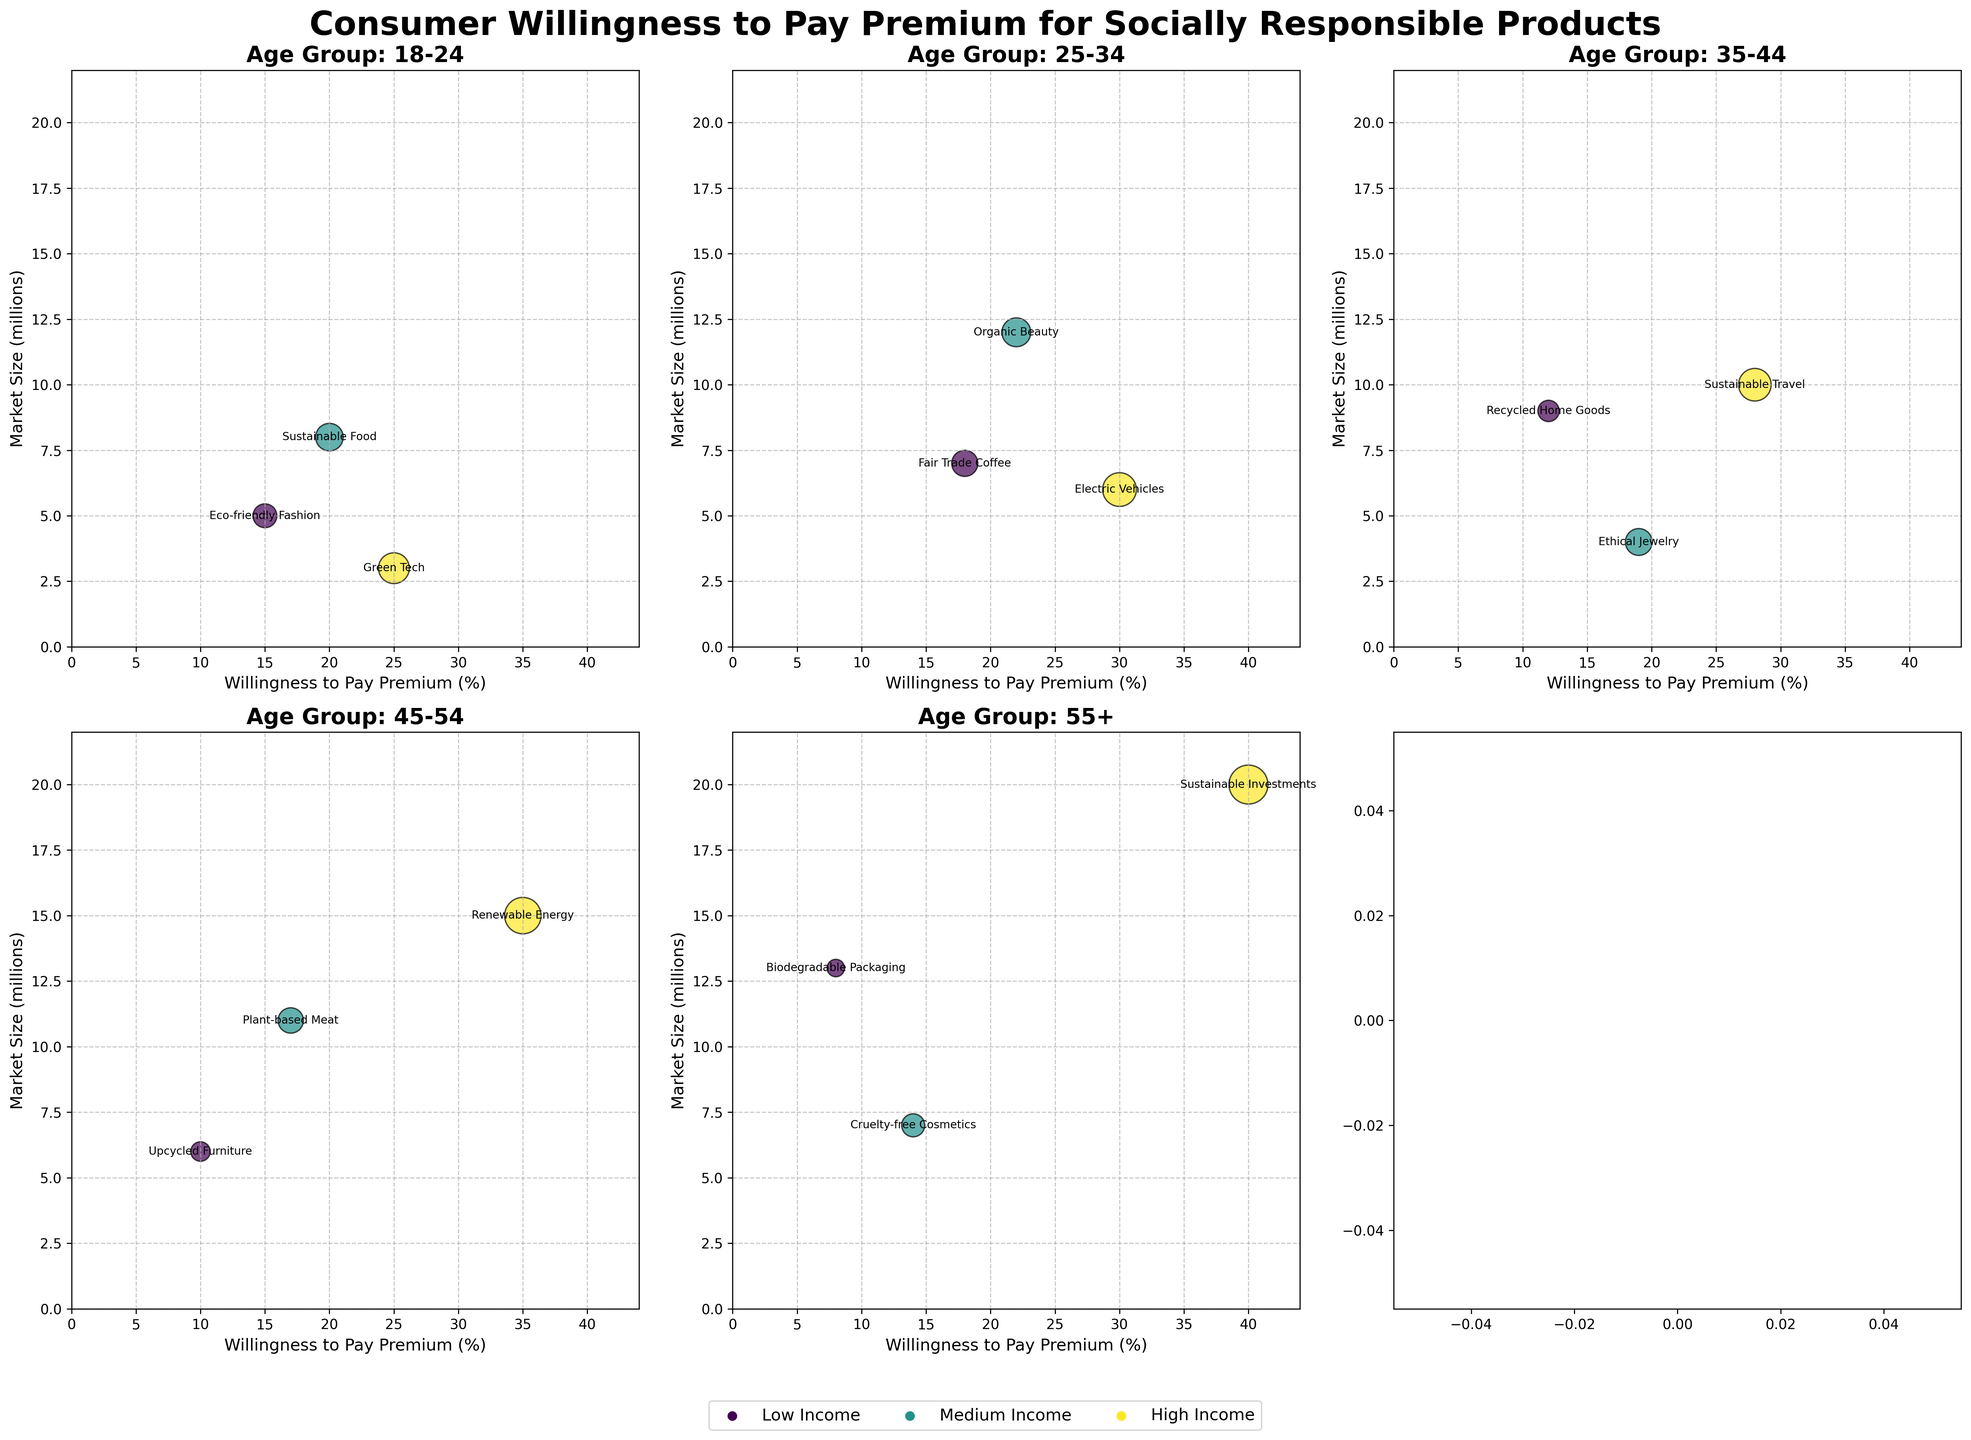What is the title of the figure? The title of the figure is displayed at the top of the plot area and usually provides an overview of what the entire figure is about.
Answer: Consumer Willingness to Pay Premium for Socially Responsible Products Which age group shows the highest willingness to pay a premium for any product? When looking at the subplots for different age groups, identify the maximum value on the x-axis labeled 'Willingness to Pay Premium (%)'.
Answer: 55+ (Sustainable Investments, 40%) What is the market size for Electric Vehicles for the age group 25-34? Find the subplot for the age group 25-34 and locate the bubble labeled 'Electric Vehicles'. The y-axis represents the market size.
Answer: 6 million How many products are represented in the age group 35-44? Count the number of bubbles in the subplot for the age group 35-44. Each bubble represents a different product.
Answer: 3 Compare the willingness to pay premiums between 18-24 and 45-54 age groups. Which age group shows more willingness to pay premiums for their products in general? Look at the x-axis ranges and individual bubble positions for the subplots of 18-24 and 45-54 age groups. Compare the positions on the x-axis for higher values.
Answer: 18-24 What is the product category for low-income individuals in the age group 45-54, and what is its willingness to pay premium percentage? Find the subplot for the age group 45-54, locate the specific bubble color corresponding to low-income levels and read its label and corresponding x-axis value.
Answer: Upcycled Furniture, 10% For the age group 25-34, what is the difference in willingness to pay premiums between Organic Beauty (Medium Income) and Fair Trade Coffee (Low Income)? Locate the bubbles for Organic Beauty and Fair Trade Coffee in the age group 25-34 subplot, look at their x-axis values, and subtract those values.
Answer: 4% How does the market size for Biodegradable Packaging in the 55+ age group compare to the market size for Renewable Energy in the 45-54 age group? Locate the bubbles for Biodegradable Packaging in the 55+ age group and Renewable Energy in the 45-54 age group, then compare their y-axis values (market size).
Answer: Biodegradable Packaging is smaller What type of income level corresponds to the highest willingness to pay for Green Tech in the age group 18-24? Find the bubble labeled 'Green Tech' in the age group 18-24 subplot and identify its color, which corresponds to the income level, then use the legend to determine the corresponding income level.
Answer: High income What trend can you observe in willingness to pay premium percentages and market sizes as the income level changes for the age group 55+? Look at the 55+ subplot and compare the bubbles for the different income levels, noticing changes in positions along both x (willingness to pay) and y (market size) axes.
Answer: Higher income correlates with higher willingness to pay and larger market size 